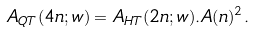<formula> <loc_0><loc_0><loc_500><loc_500>A _ { Q T } ( 4 n ; w ) = A _ { H T } ( 2 n ; w ) . A ( n ) ^ { 2 } .</formula> 